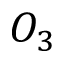Convert formula to latex. <formula><loc_0><loc_0><loc_500><loc_500>O _ { 3 }</formula> 